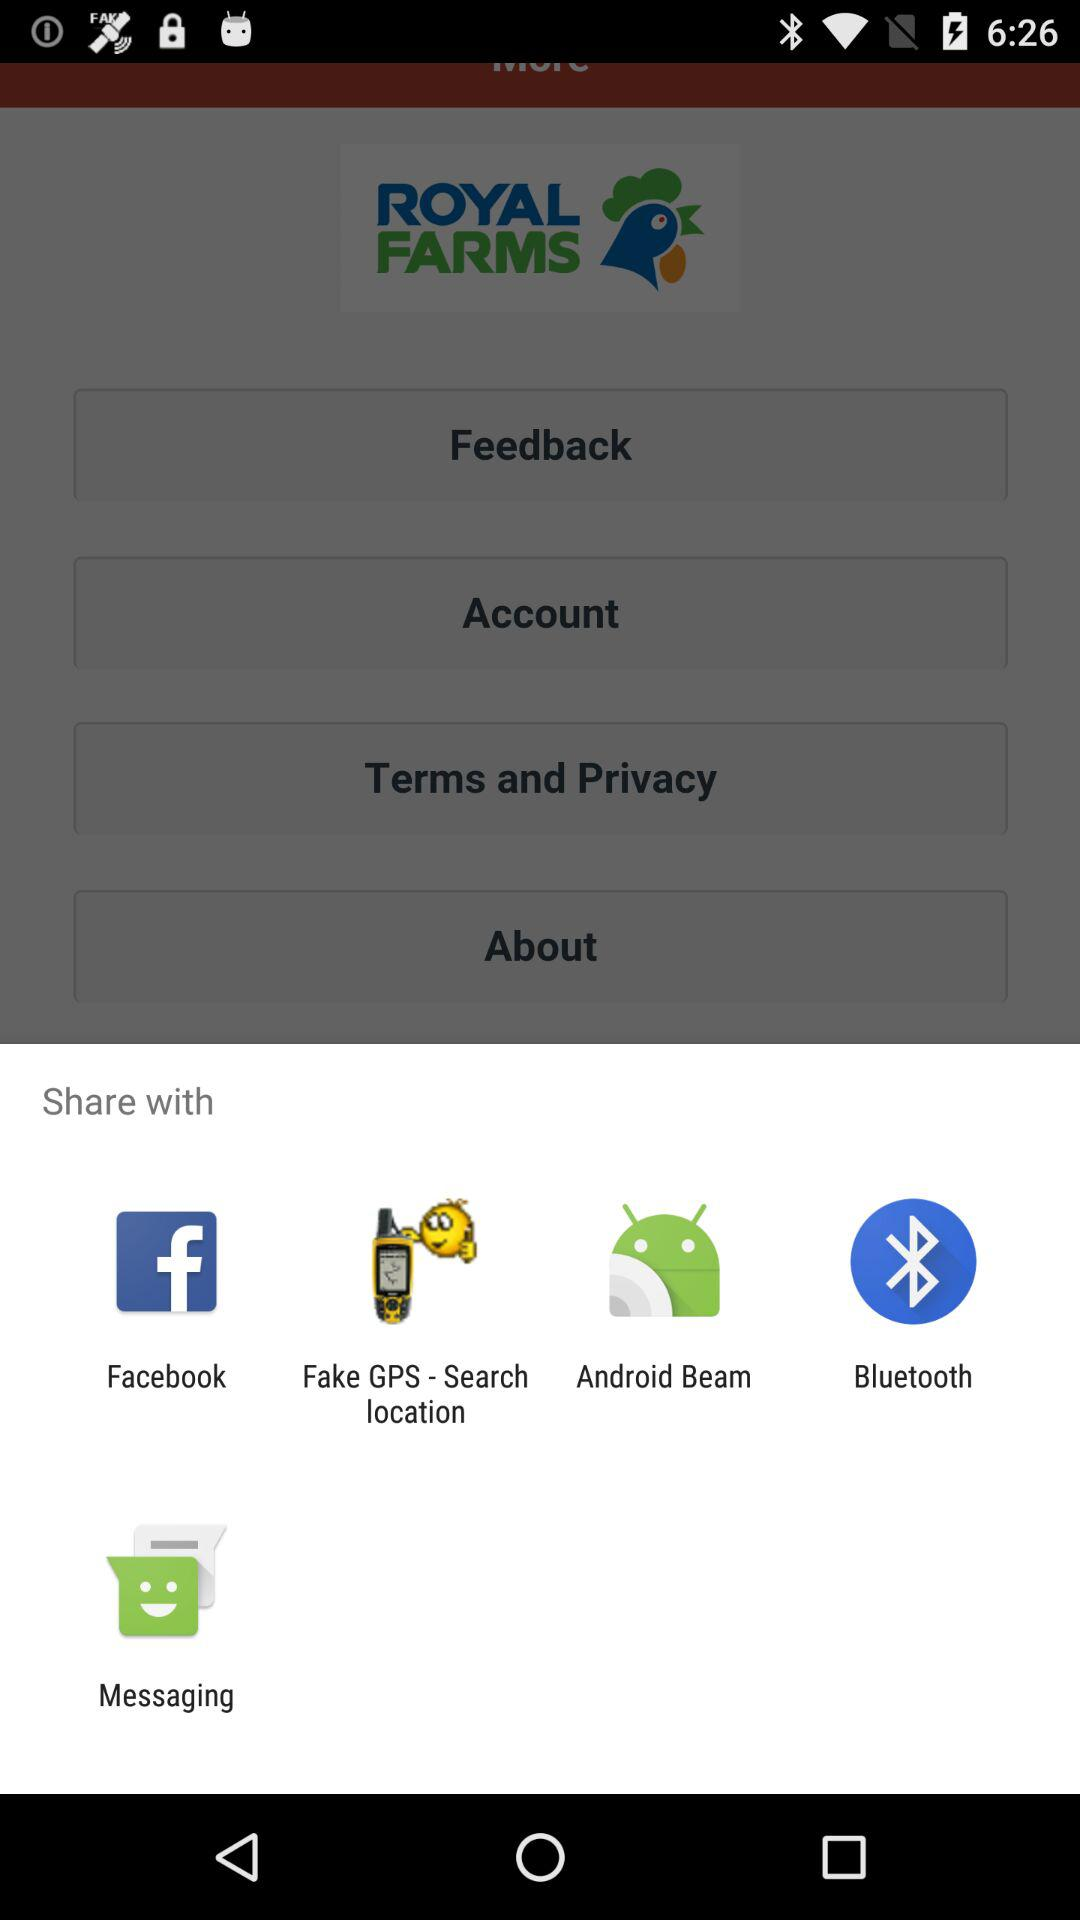What application can be used to share? You can use "Facebook", "Fake GPS - Search location", "Android Beam", "Bluetooth", and "Messaging". 